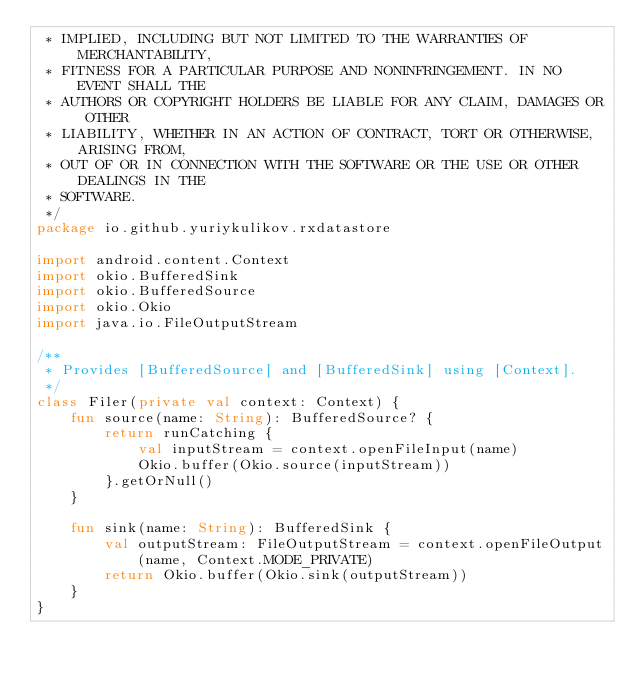<code> <loc_0><loc_0><loc_500><loc_500><_Kotlin_> * IMPLIED, INCLUDING BUT NOT LIMITED TO THE WARRANTIES OF MERCHANTABILITY,
 * FITNESS FOR A PARTICULAR PURPOSE AND NONINFRINGEMENT. IN NO EVENT SHALL THE
 * AUTHORS OR COPYRIGHT HOLDERS BE LIABLE FOR ANY CLAIM, DAMAGES OR OTHER
 * LIABILITY, WHETHER IN AN ACTION OF CONTRACT, TORT OR OTHERWISE, ARISING FROM,
 * OUT OF OR IN CONNECTION WITH THE SOFTWARE OR THE USE OR OTHER DEALINGS IN THE
 * SOFTWARE.
 */
package io.github.yuriykulikov.rxdatastore

import android.content.Context
import okio.BufferedSink
import okio.BufferedSource
import okio.Okio
import java.io.FileOutputStream

/**
 * Provides [BufferedSource] and [BufferedSink] using [Context].
 */
class Filer(private val context: Context) {
    fun source(name: String): BufferedSource? {
        return runCatching {
            val inputStream = context.openFileInput(name)
            Okio.buffer(Okio.source(inputStream))
        }.getOrNull()
    }

    fun sink(name: String): BufferedSink {
        val outputStream: FileOutputStream = context.openFileOutput(name, Context.MODE_PRIVATE)
        return Okio.buffer(Okio.sink(outputStream))
    }
}
</code> 